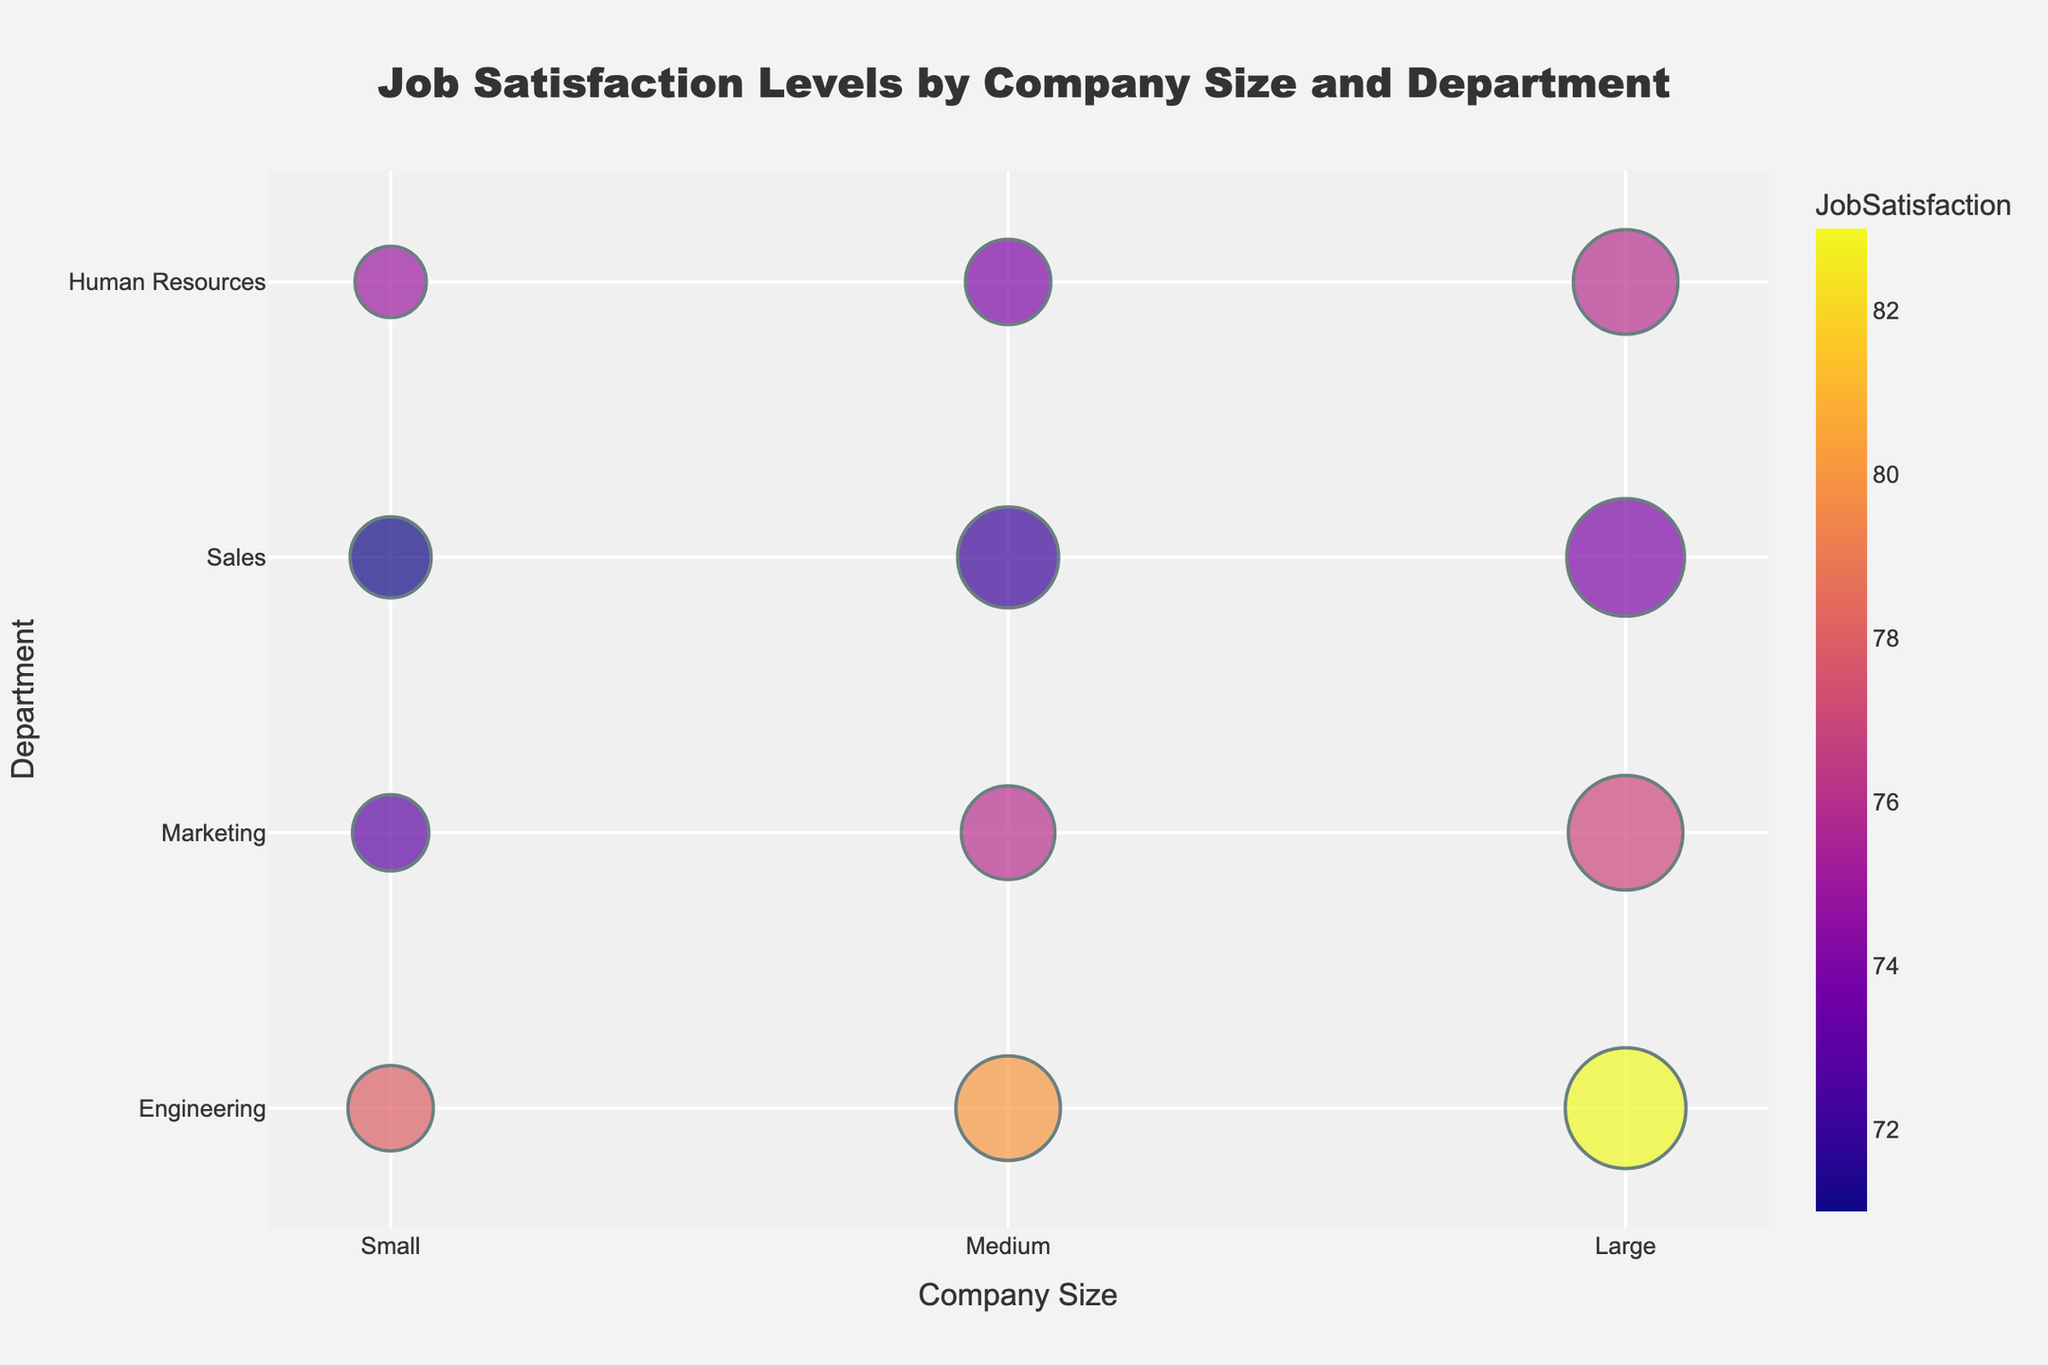What's the title of the chart? The title of the chart is located at the top and typically summarizes the content of the visual. Reading the title directly provides the answer.
Answer: Job Satisfaction Levels by Company Size and Department Which company size has the highest job satisfaction in the Engineering department? Locate the "Engineering" department on the y-axis and compare the job satisfaction values across different company sizes (Small, Medium, Large) represented on the x-axis.
Answer: Large What is the difference in job satisfaction between Small and Large companies in the Sales department? Find the job satisfaction values for the Sales department in both Small and Large companies on the chart (71 for Small, 74 for Large). Subtract the value of Small from Large (74 - 71).
Answer: 3 How many employees are represented by the bubble size in the Medium company’s Marketing department? Locate the Medium company size on the x-axis and the Marketing department on the y-axis. The bubble size legend or tooltip will indicate the number of employees represented.
Answer: 60 Which department has the smallest bubble size in Large companies? Look for the smallest bubble within the Large company size on the x-axis and identify the corresponding department on the y-axis.
Answer: Human Resources Compare the job satisfaction levels between Engineering and Marketing departments in Medium companies. Which one is higher? Find the job satisfaction values for both Engineering (80) and Marketing (76) departments within Medium companies. Compare them to determine which is higher.
Answer: Engineering What is the average job satisfaction across all departments in Small companies? Locate all departments within Small companies and average their job satisfaction values: (78 + 73 + 71 + 75)/4 = 74.25.
Answer: 74.25 How does the bubble size for Sales in Large companies compare to the bubble size for Human Resources in Medium companies? Compare the bubble sizes directly by locating them on the chart (19 for Sales in Large and 10 for Human Resources in Medium).
Answer: Larger Reflecting on the entire chart, which company size seems to have the highest overall job satisfaction? Compare the job satisfaction bubbles across different company sizes and find the company size that generally has the highest values.
Answer: Large Which department in Medium companies has the lowest job satisfaction? Find all department values within Medium companies and identify the one with the lowest job satisfaction (72 for Sales).
Answer: Sales 